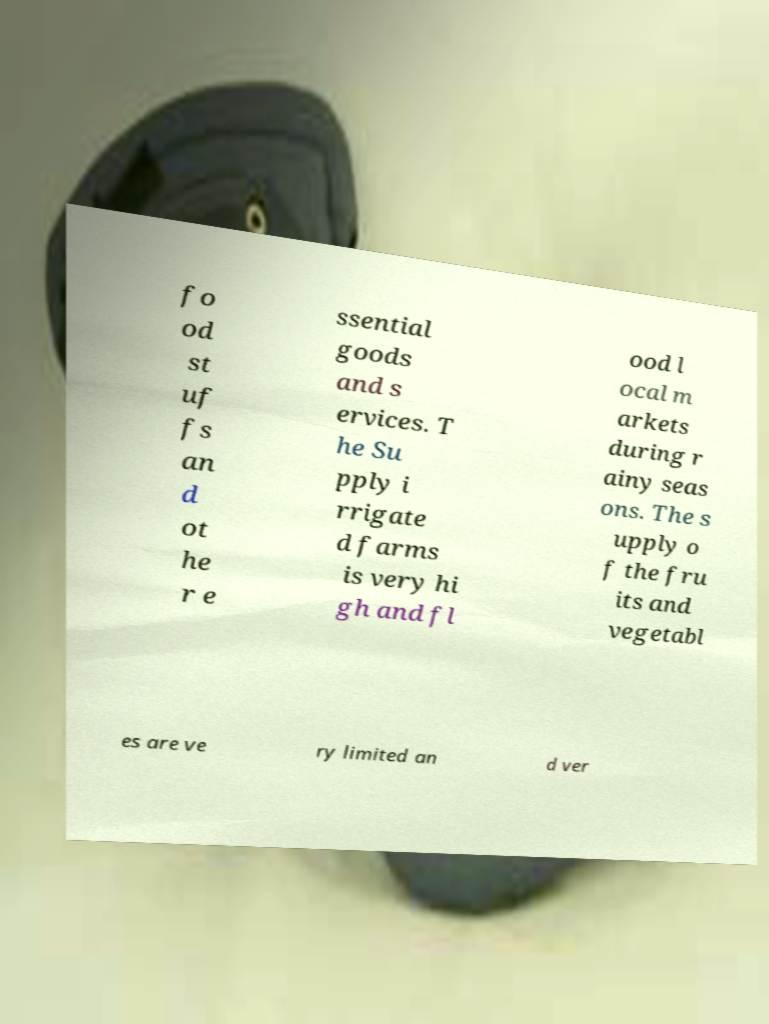Can you accurately transcribe the text from the provided image for me? fo od st uf fs an d ot he r e ssential goods and s ervices. T he Su pply i rrigate d farms is very hi gh and fl ood l ocal m arkets during r ainy seas ons. The s upply o f the fru its and vegetabl es are ve ry limited an d ver 